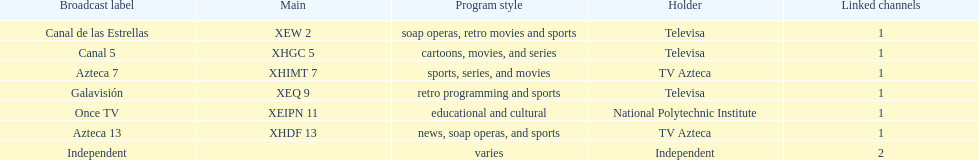What is the difference between the number of affiliates galavision has and the number of affiliates azteca 13 has? 0. 